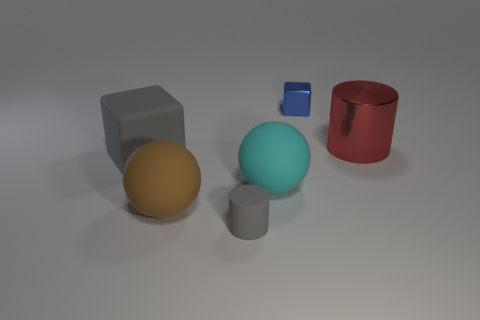Add 4 gray things. How many objects exist? 10 Subtract all balls. How many objects are left? 4 Subtract 0 blue spheres. How many objects are left? 6 Subtract all small blue metal cubes. Subtract all gray matte cubes. How many objects are left? 4 Add 1 brown objects. How many brown objects are left? 2 Add 3 big things. How many big things exist? 7 